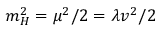<formula> <loc_0><loc_0><loc_500><loc_500>m _ { H } ^ { 2 } = \mu ^ { 2 } / 2 = \lambda v ^ { 2 } / 2</formula> 